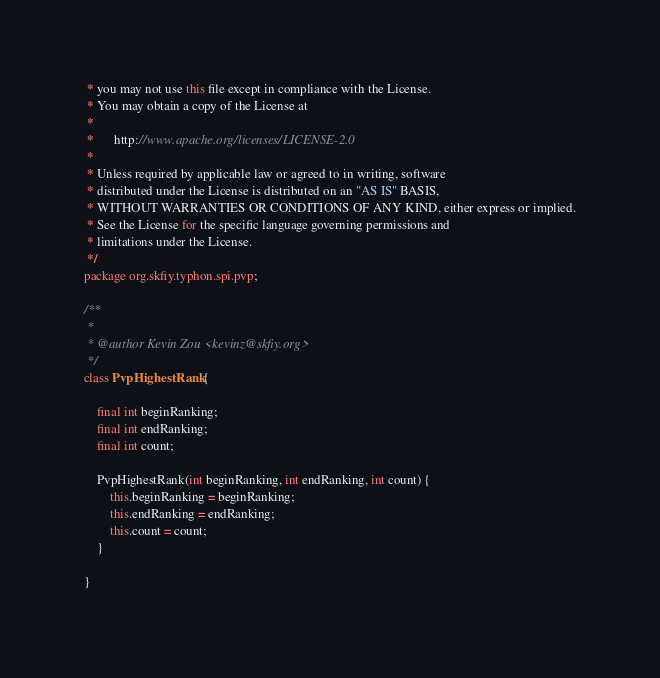Convert code to text. <code><loc_0><loc_0><loc_500><loc_500><_Java_> * you may not use this file except in compliance with the License.
 * You may obtain a copy of the License at
 *
 *      http://www.apache.org/licenses/LICENSE-2.0
 *
 * Unless required by applicable law or agreed to in writing, software
 * distributed under the License is distributed on an "AS IS" BASIS,
 * WITHOUT WARRANTIES OR CONDITIONS OF ANY KIND, either express or implied.
 * See the License for the specific language governing permissions and
 * limitations under the License.
 */
package org.skfiy.typhon.spi.pvp;

/**
 *
 * @author Kevin Zou <kevinz@skfiy.org>
 */
class PvpHighestRank {

    final int beginRanking;
    final int endRanking;
    final int count;

    PvpHighestRank(int beginRanking, int endRanking, int count) {
        this.beginRanking = beginRanking;
        this.endRanking = endRanking;
        this.count = count;
    }

}
</code> 